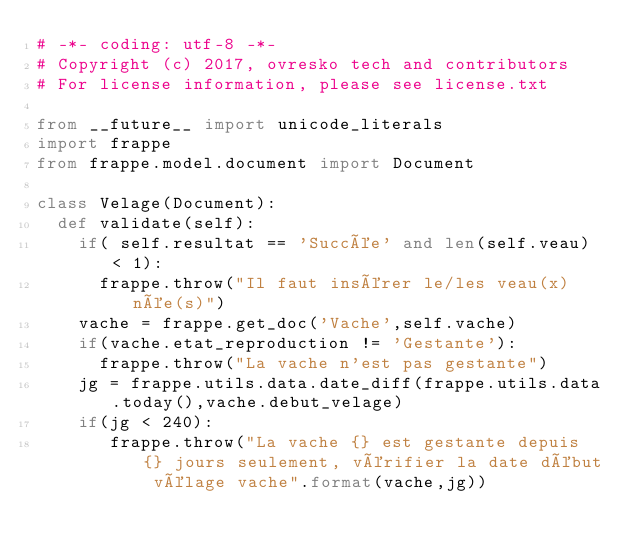<code> <loc_0><loc_0><loc_500><loc_500><_Python_># -*- coding: utf-8 -*-
# Copyright (c) 2017, ovresko tech and contributors
# For license information, please see license.txt

from __future__ import unicode_literals
import frappe
from frappe.model.document import Document

class Velage(Document):
	def validate(self):
		if( self.resultat == 'Succée' and len(self.veau) < 1):
			frappe.throw("Il faut insérer le/les veau(x) née(s)")
		vache = frappe.get_doc('Vache',self.vache)
		if(vache.etat_reproduction != 'Gestante'):
			frappe.throw("La vache n'est pas gestante")
		jg = frappe.utils.data.date_diff(frappe.utils.data.today(),vache.debut_velage)
		if(jg < 240):
			 frappe.throw("La vache {} est gestante depuis {} jours seulement, vérifier la date début vélage vache".format(vache,jg))
</code> 